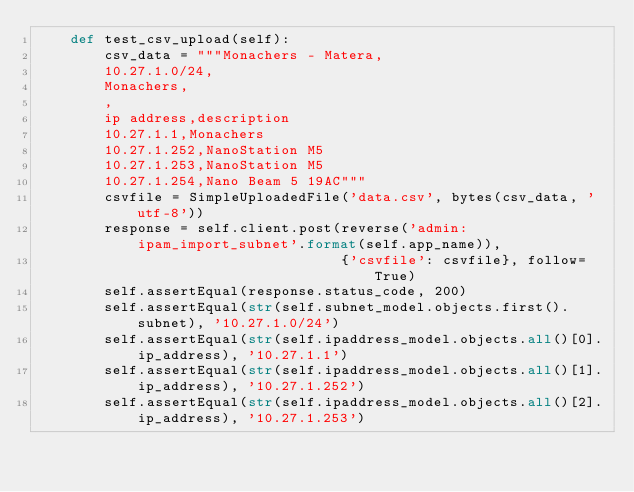<code> <loc_0><loc_0><loc_500><loc_500><_Python_>    def test_csv_upload(self):
        csv_data = """Monachers - Matera,
        10.27.1.0/24,
        Monachers,
        ,
        ip address,description
        10.27.1.1,Monachers
        10.27.1.252,NanoStation M5
        10.27.1.253,NanoStation M5
        10.27.1.254,Nano Beam 5 19AC"""
        csvfile = SimpleUploadedFile('data.csv', bytes(csv_data, 'utf-8'))
        response = self.client.post(reverse('admin:ipam_import_subnet'.format(self.app_name)),
                                    {'csvfile': csvfile}, follow=True)
        self.assertEqual(response.status_code, 200)
        self.assertEqual(str(self.subnet_model.objects.first().subnet), '10.27.1.0/24')
        self.assertEqual(str(self.ipaddress_model.objects.all()[0].ip_address), '10.27.1.1')
        self.assertEqual(str(self.ipaddress_model.objects.all()[1].ip_address), '10.27.1.252')
        self.assertEqual(str(self.ipaddress_model.objects.all()[2].ip_address), '10.27.1.253')</code> 